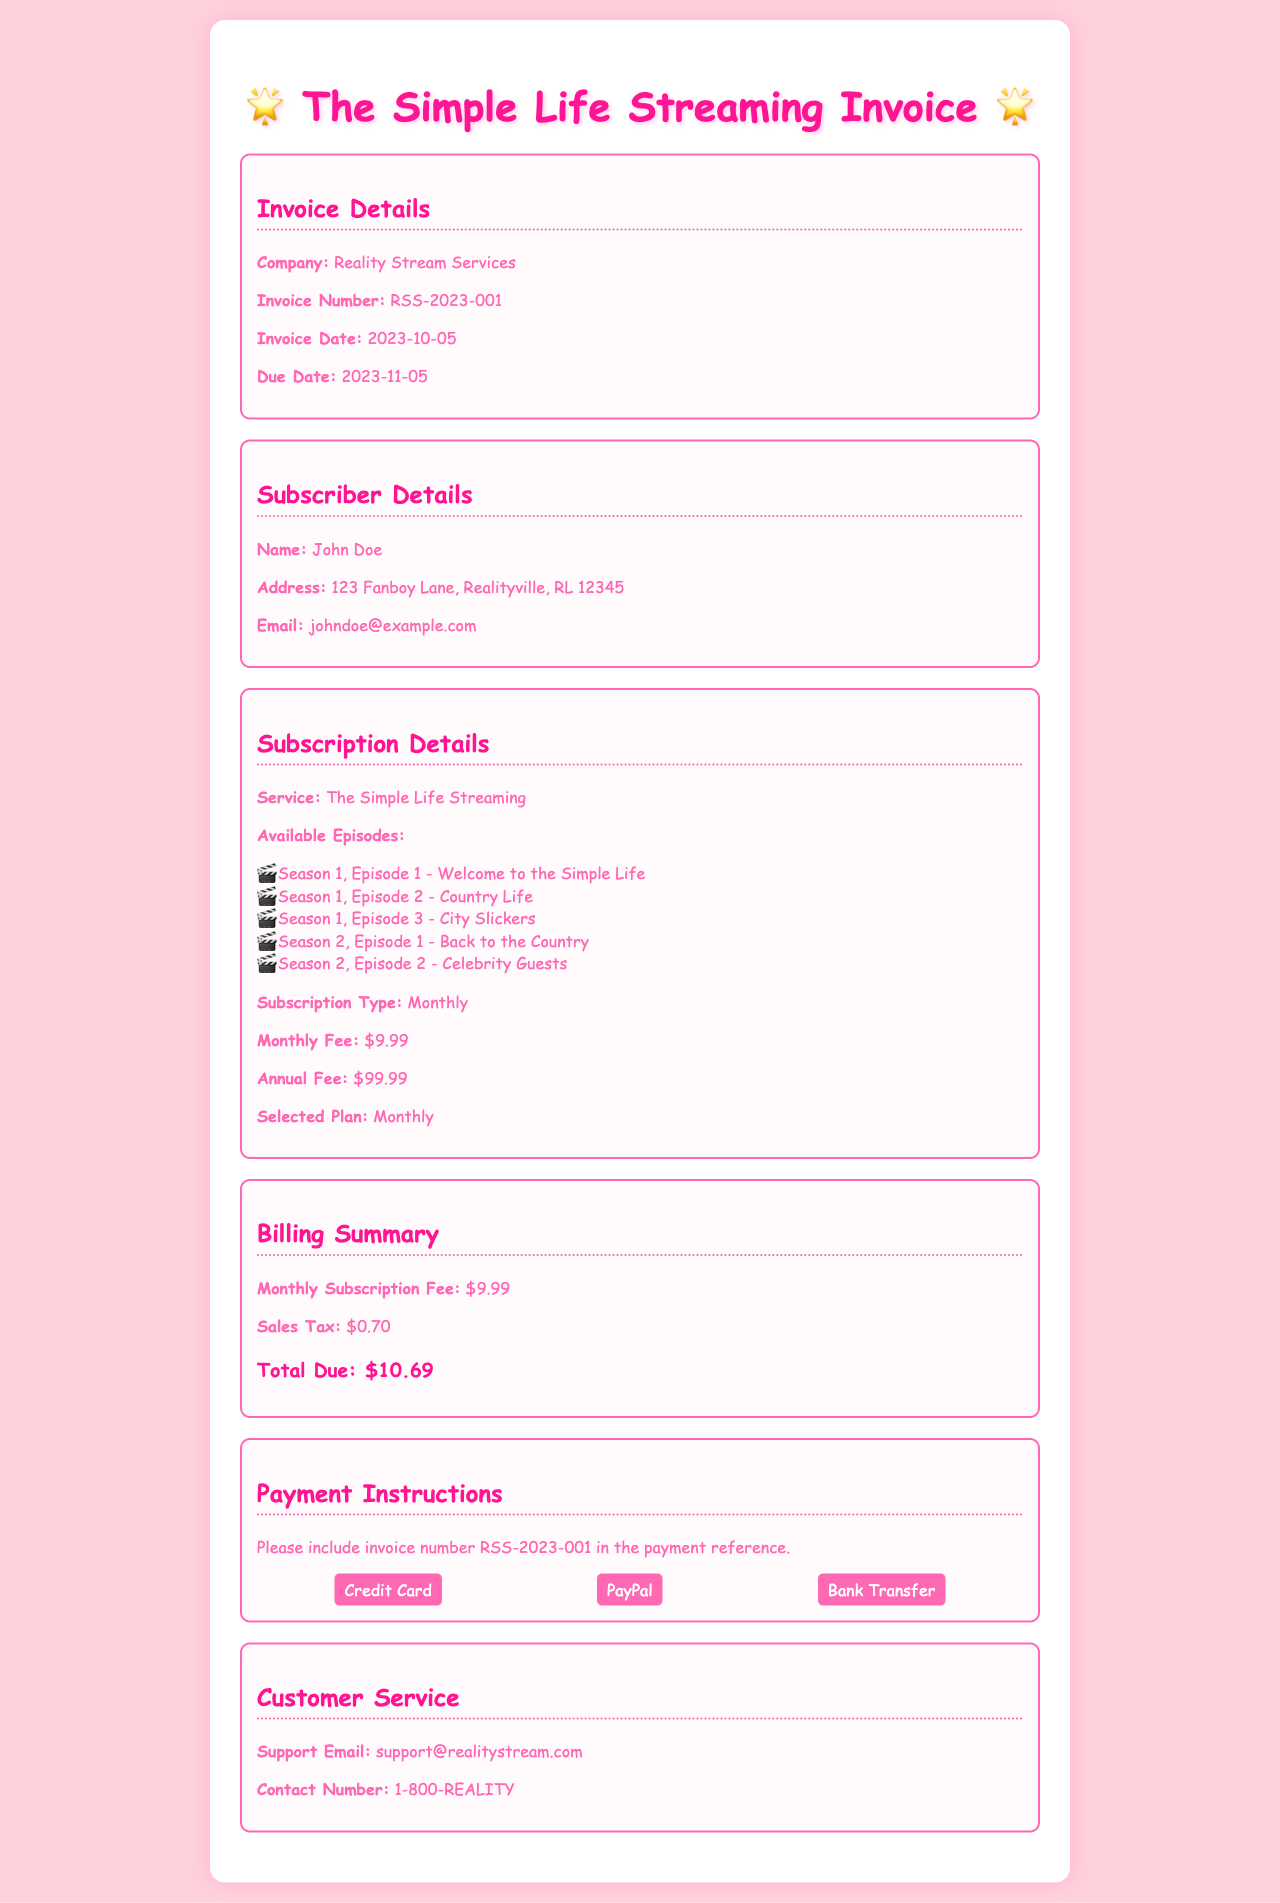What is the company name? The company name is listed in the invoice details section.
Answer: Reality Stream Services What is the invoice number? The invoice number can be found in the Invoice Details section.
Answer: RSS-2023-001 What is the monthly fee for the subscription? The monthly fee is stated in the Subscription Details section.
Answer: $9.99 What date is the invoice due? The due date is provided in the Invoice Details section.
Answer: 2023-11-05 How many available episodes are listed? The number of available episodes can be counted in the Subscription Details section.
Answer: 5 What is the total due amount? The total due is indicated in the Billing Summary section.
Answer: $10.69 What payment methods are accepted? The accepted payment methods are listed in the Payment Instructions section.
Answer: Credit Card, PayPal, Bank Transfer What is the name of the subscriber? The subscriber's name is found in the Subscriber Details section.
Answer: John Doe What type of subscription is selected? The selected subscription type is specified in the Subscription Details section.
Answer: Monthly 